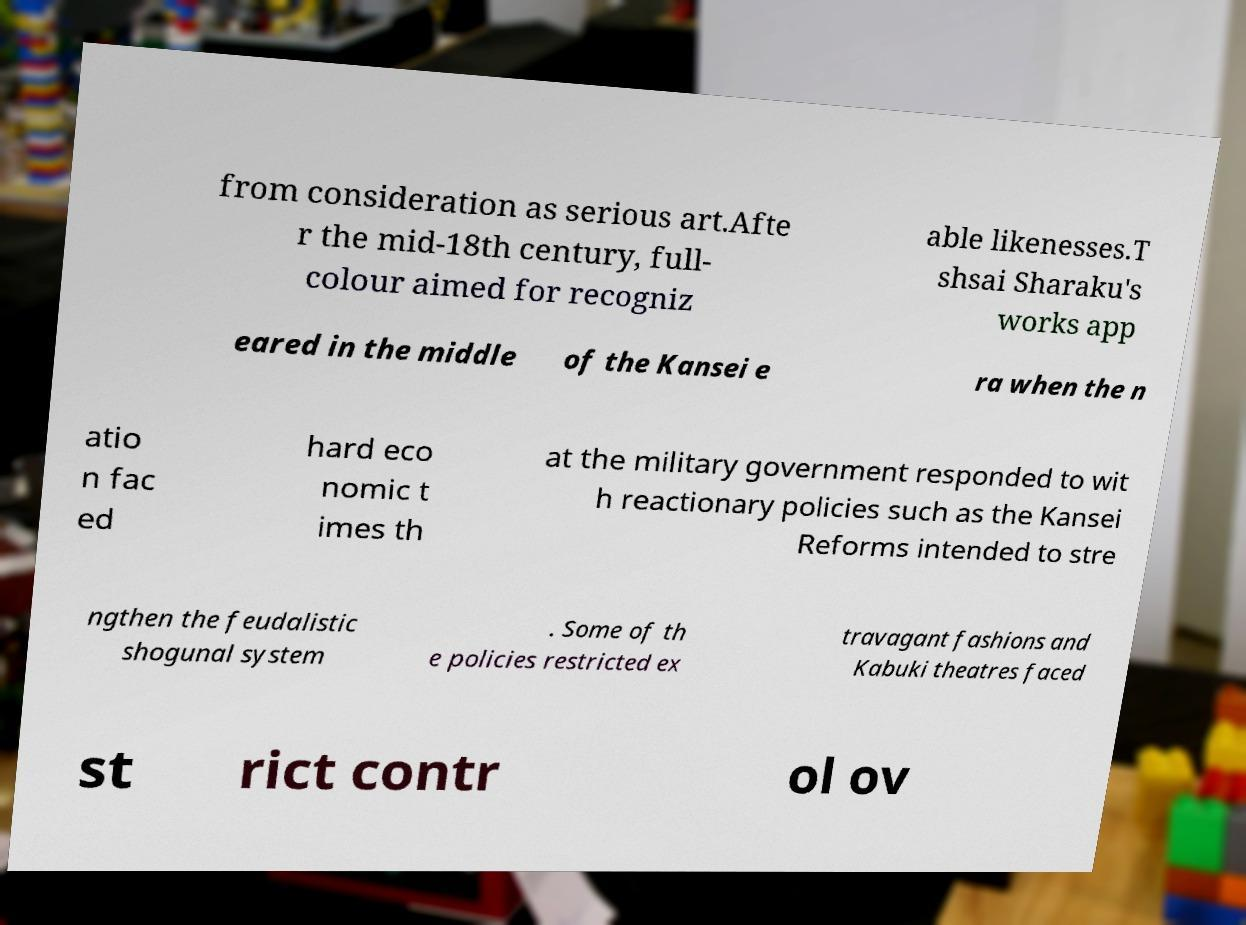What messages or text are displayed in this image? I need them in a readable, typed format. from consideration as serious art.Afte r the mid-18th century, full- colour aimed for recogniz able likenesses.T shsai Sharaku's works app eared in the middle of the Kansei e ra when the n atio n fac ed hard eco nomic t imes th at the military government responded to wit h reactionary policies such as the Kansei Reforms intended to stre ngthen the feudalistic shogunal system . Some of th e policies restricted ex travagant fashions and Kabuki theatres faced st rict contr ol ov 